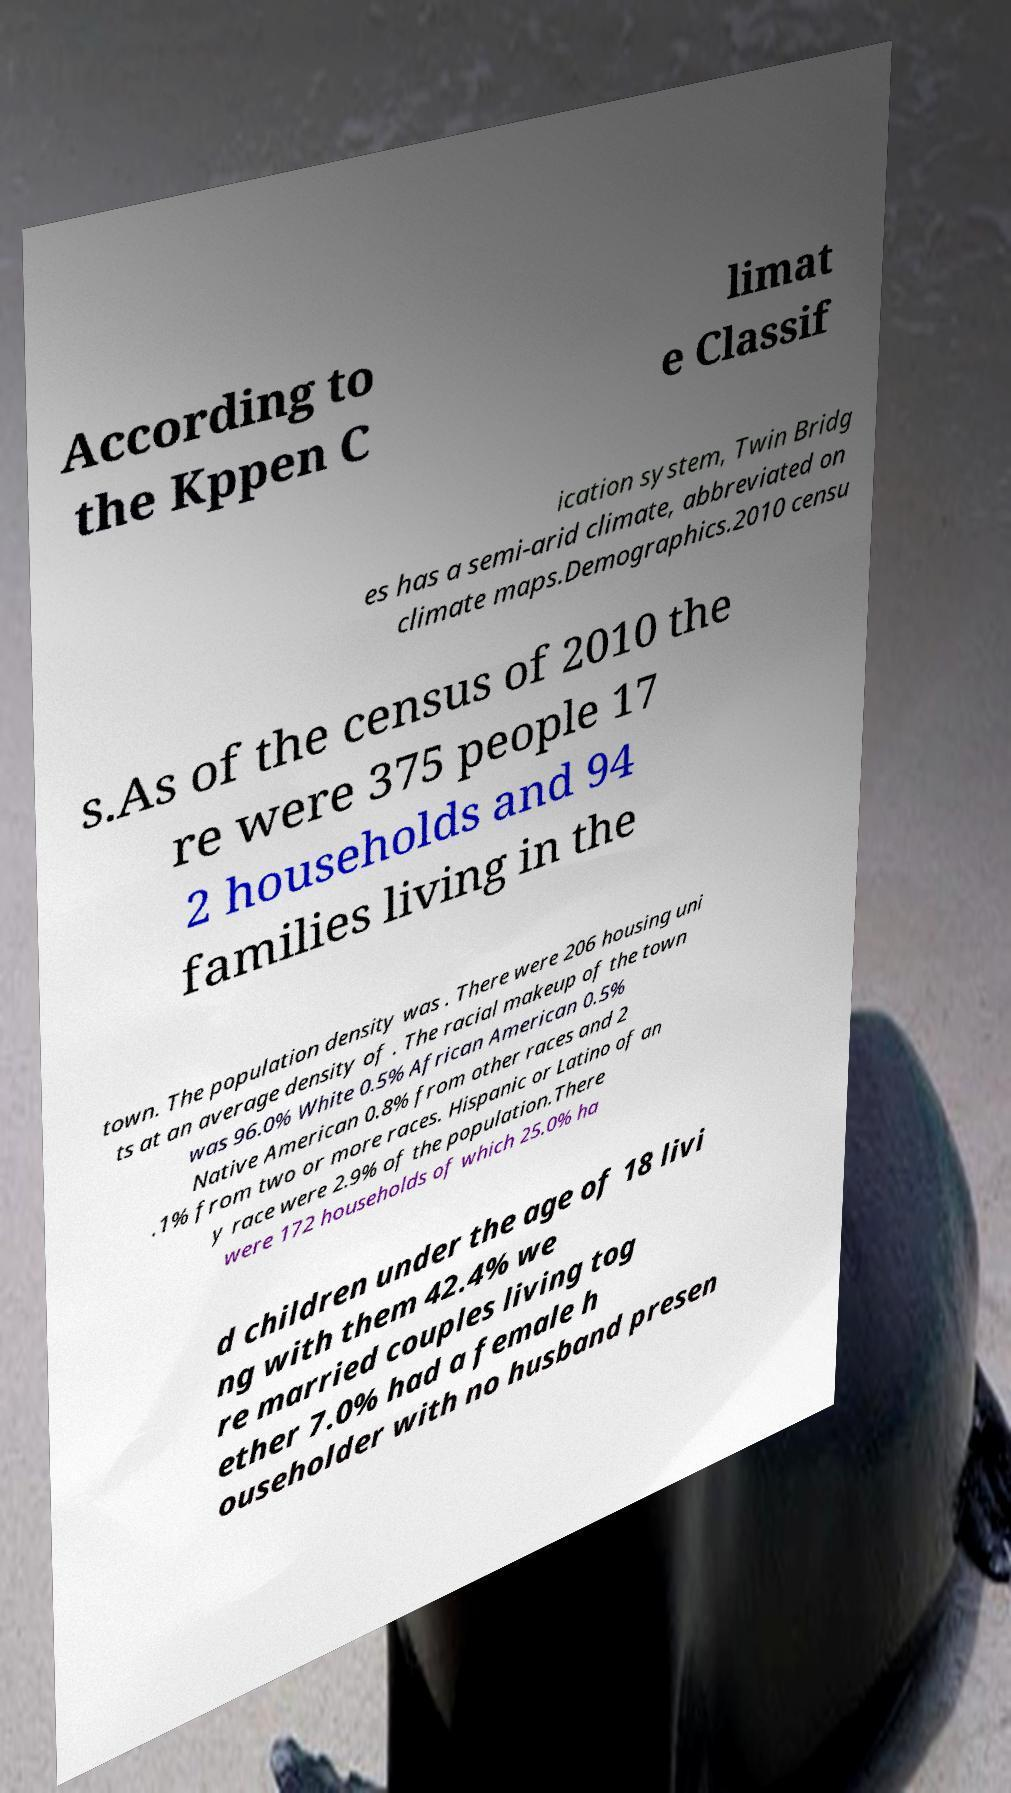Could you extract and type out the text from this image? According to the Kppen C limat e Classif ication system, Twin Bridg es has a semi-arid climate, abbreviated on climate maps.Demographics.2010 censu s.As of the census of 2010 the re were 375 people 17 2 households and 94 families living in the town. The population density was . There were 206 housing uni ts at an average density of . The racial makeup of the town was 96.0% White 0.5% African American 0.5% Native American 0.8% from other races and 2 .1% from two or more races. Hispanic or Latino of an y race were 2.9% of the population.There were 172 households of which 25.0% ha d children under the age of 18 livi ng with them 42.4% we re married couples living tog ether 7.0% had a female h ouseholder with no husband presen 